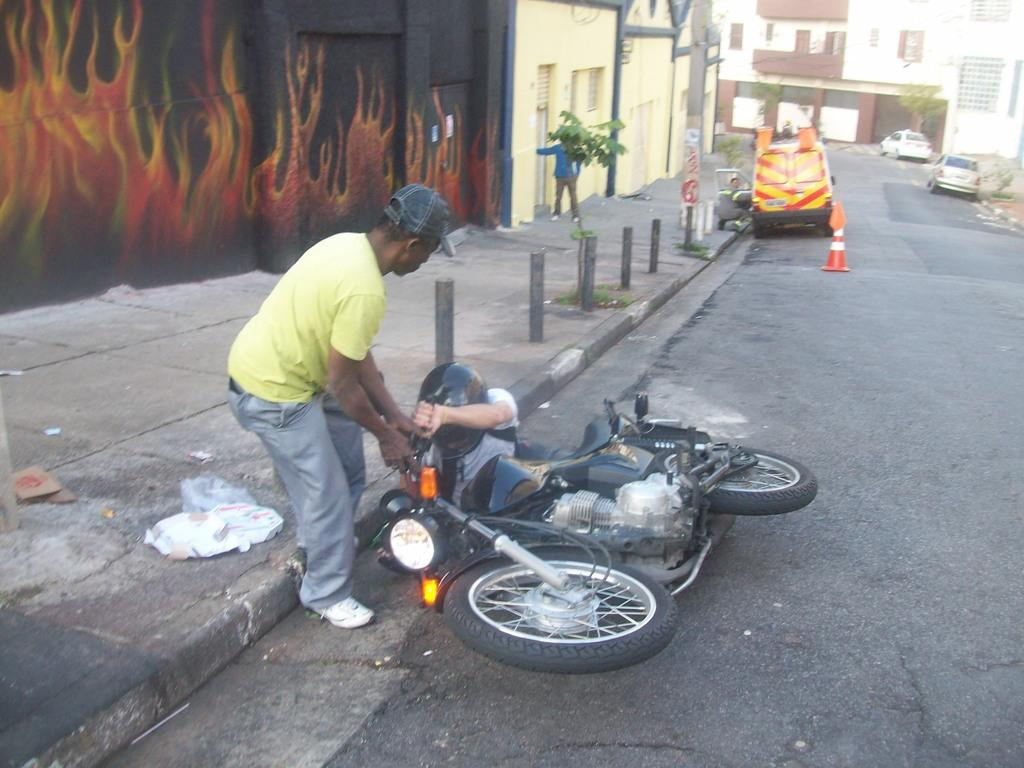How many people are in the image? There are two people in the image. What can be seen on the road in the image? There is a bike on the road in the image. What is visible in the background of the image? There are buildings and cars parked on the side of the road in the background. Can you tell me the name of the stranger who handed the receipt to the person in the image? There is no stranger or receipt present in the image. What is the cause of death for the person in the image? There is no indication of death or any related information in the image. 